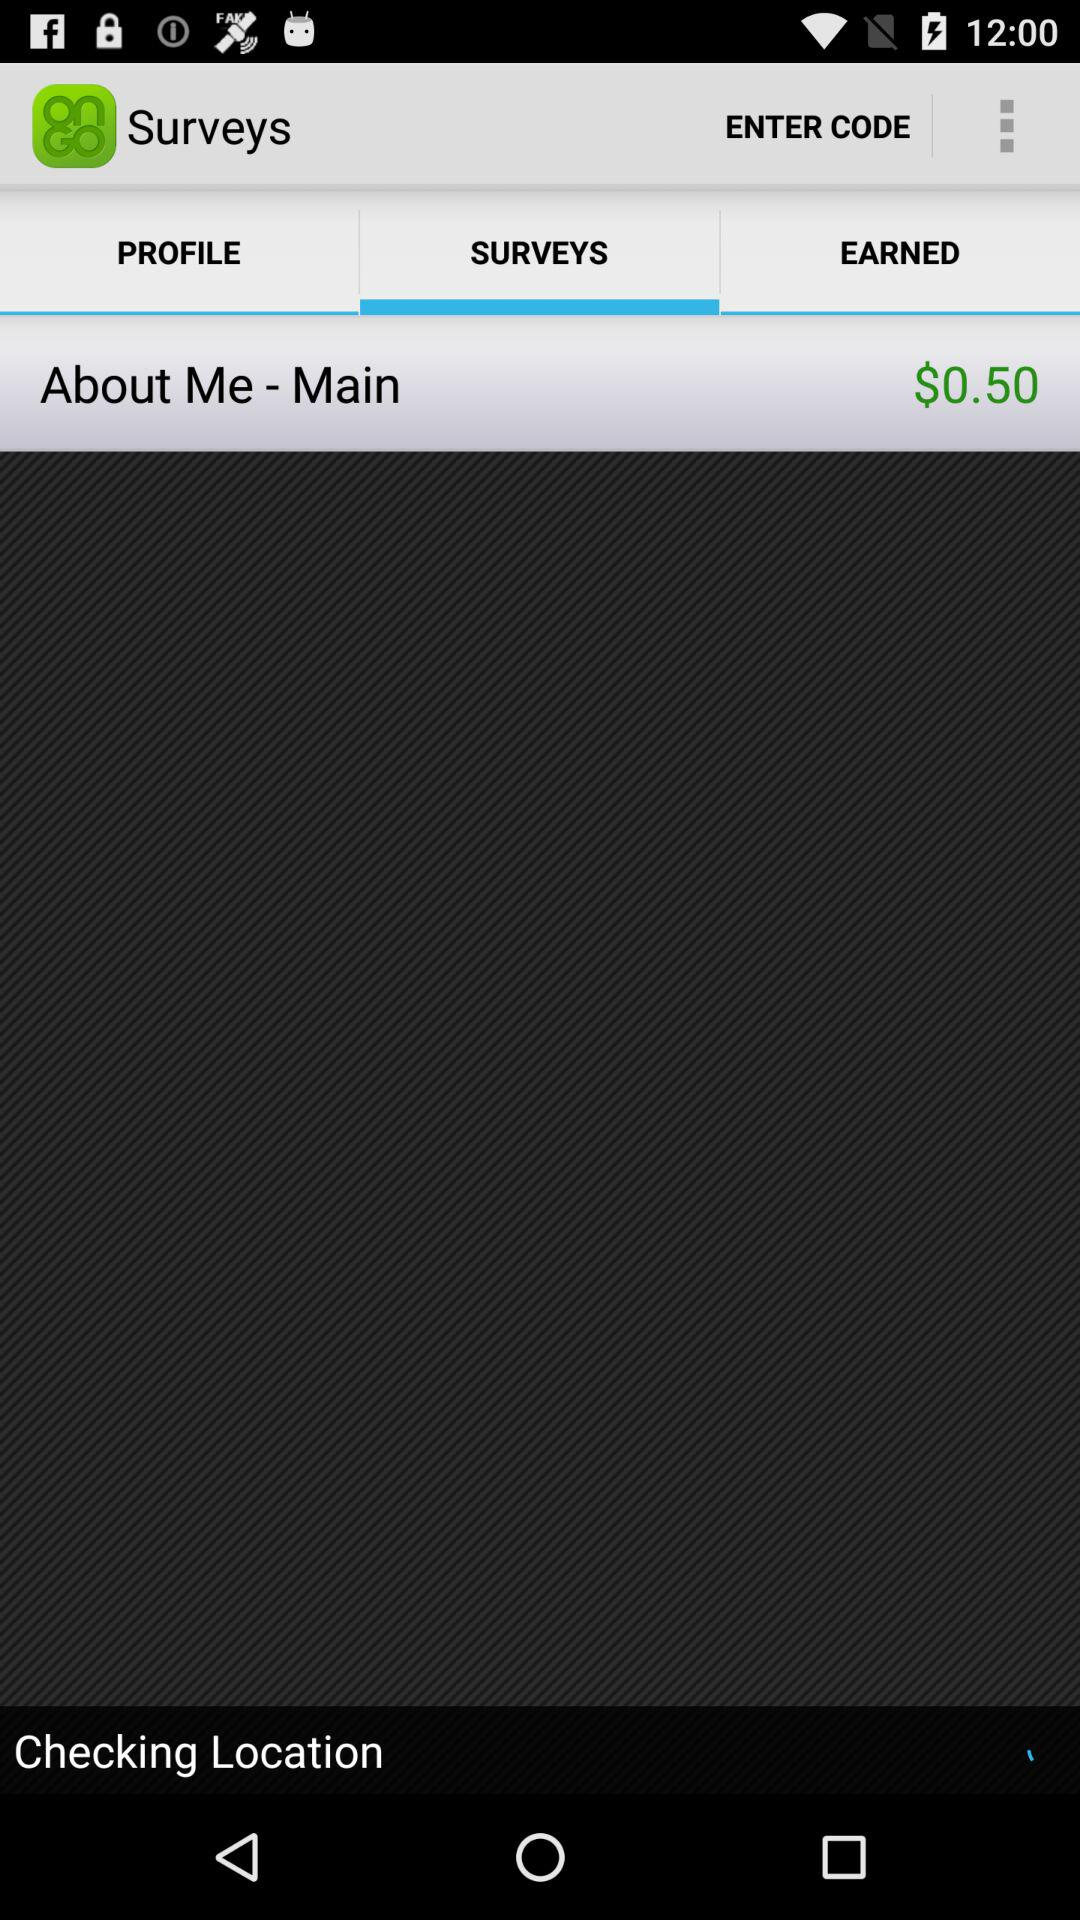Which tab is selected? The selected tab is "SURVEYS". 